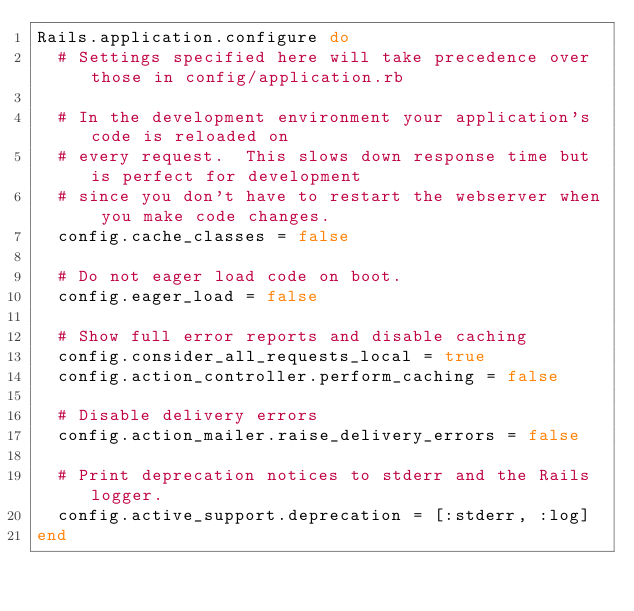Convert code to text. <code><loc_0><loc_0><loc_500><loc_500><_Ruby_>Rails.application.configure do
  # Settings specified here will take precedence over those in config/application.rb

  # In the development environment your application's code is reloaded on
  # every request.  This slows down response time but is perfect for development
  # since you don't have to restart the webserver when you make code changes.
  config.cache_classes = false

  # Do not eager load code on boot.
  config.eager_load = false

  # Show full error reports and disable caching
  config.consider_all_requests_local = true
  config.action_controller.perform_caching = false

  # Disable delivery errors
  config.action_mailer.raise_delivery_errors = false

  # Print deprecation notices to stderr and the Rails logger.
  config.active_support.deprecation = [:stderr, :log]
end
</code> 